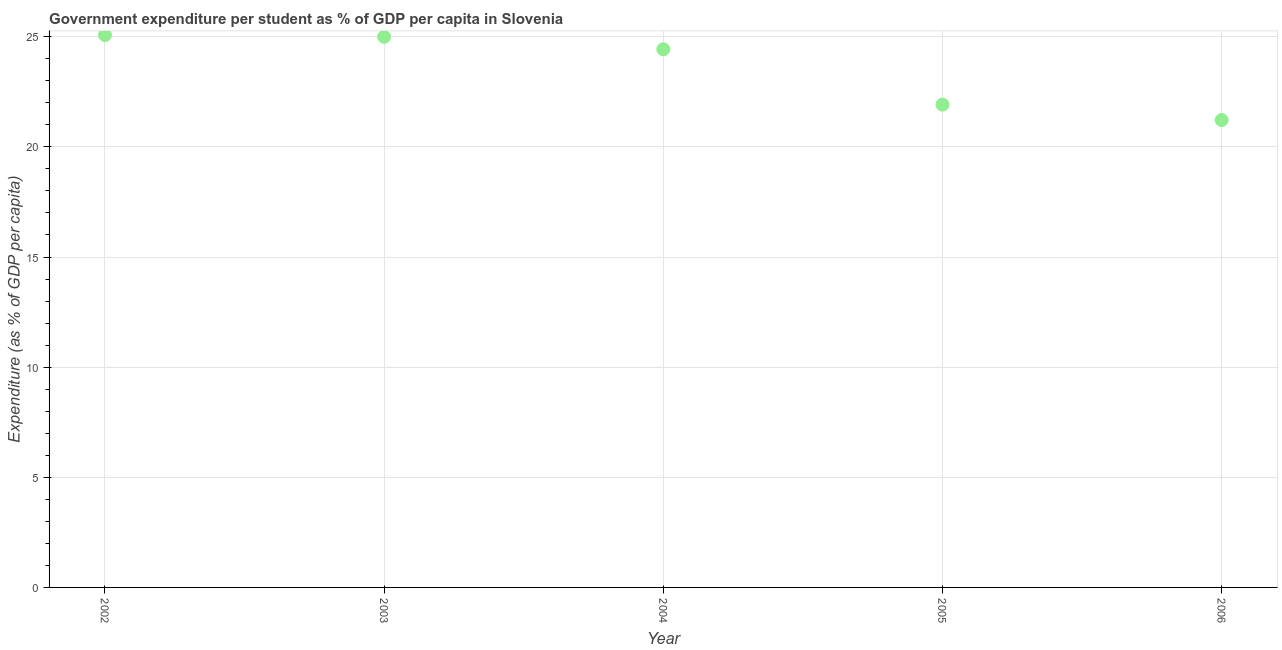What is the government expenditure per student in 2004?
Your response must be concise. 24.43. Across all years, what is the maximum government expenditure per student?
Ensure brevity in your answer.  25.08. Across all years, what is the minimum government expenditure per student?
Offer a very short reply. 21.22. In which year was the government expenditure per student maximum?
Your response must be concise. 2002. In which year was the government expenditure per student minimum?
Your answer should be very brief. 2006. What is the sum of the government expenditure per student?
Your answer should be very brief. 117.64. What is the difference between the government expenditure per student in 2002 and 2006?
Give a very brief answer. 3.86. What is the average government expenditure per student per year?
Provide a succinct answer. 23.53. What is the median government expenditure per student?
Offer a very short reply. 24.43. Do a majority of the years between 2006 and 2002 (inclusive) have government expenditure per student greater than 9 %?
Provide a short and direct response. Yes. What is the ratio of the government expenditure per student in 2002 to that in 2004?
Provide a short and direct response. 1.03. Is the government expenditure per student in 2003 less than that in 2006?
Provide a short and direct response. No. What is the difference between the highest and the second highest government expenditure per student?
Give a very brief answer. 0.08. What is the difference between the highest and the lowest government expenditure per student?
Give a very brief answer. 3.86. How many dotlines are there?
Ensure brevity in your answer.  1. How many years are there in the graph?
Your answer should be compact. 5. What is the difference between two consecutive major ticks on the Y-axis?
Ensure brevity in your answer.  5. What is the title of the graph?
Offer a very short reply. Government expenditure per student as % of GDP per capita in Slovenia. What is the label or title of the X-axis?
Make the answer very short. Year. What is the label or title of the Y-axis?
Your answer should be very brief. Expenditure (as % of GDP per capita). What is the Expenditure (as % of GDP per capita) in 2002?
Give a very brief answer. 25.08. What is the Expenditure (as % of GDP per capita) in 2003?
Offer a very short reply. 25. What is the Expenditure (as % of GDP per capita) in 2004?
Provide a short and direct response. 24.43. What is the Expenditure (as % of GDP per capita) in 2005?
Offer a very short reply. 21.92. What is the Expenditure (as % of GDP per capita) in 2006?
Provide a succinct answer. 21.22. What is the difference between the Expenditure (as % of GDP per capita) in 2002 and 2003?
Give a very brief answer. 0.08. What is the difference between the Expenditure (as % of GDP per capita) in 2002 and 2004?
Make the answer very short. 0.64. What is the difference between the Expenditure (as % of GDP per capita) in 2002 and 2005?
Provide a succinct answer. 3.16. What is the difference between the Expenditure (as % of GDP per capita) in 2002 and 2006?
Ensure brevity in your answer.  3.86. What is the difference between the Expenditure (as % of GDP per capita) in 2003 and 2004?
Ensure brevity in your answer.  0.57. What is the difference between the Expenditure (as % of GDP per capita) in 2003 and 2005?
Ensure brevity in your answer.  3.08. What is the difference between the Expenditure (as % of GDP per capita) in 2003 and 2006?
Provide a succinct answer. 3.78. What is the difference between the Expenditure (as % of GDP per capita) in 2004 and 2005?
Provide a short and direct response. 2.51. What is the difference between the Expenditure (as % of GDP per capita) in 2004 and 2006?
Offer a very short reply. 3.21. What is the difference between the Expenditure (as % of GDP per capita) in 2005 and 2006?
Give a very brief answer. 0.7. What is the ratio of the Expenditure (as % of GDP per capita) in 2002 to that in 2004?
Ensure brevity in your answer.  1.03. What is the ratio of the Expenditure (as % of GDP per capita) in 2002 to that in 2005?
Ensure brevity in your answer.  1.14. What is the ratio of the Expenditure (as % of GDP per capita) in 2002 to that in 2006?
Make the answer very short. 1.18. What is the ratio of the Expenditure (as % of GDP per capita) in 2003 to that in 2004?
Your response must be concise. 1.02. What is the ratio of the Expenditure (as % of GDP per capita) in 2003 to that in 2005?
Your response must be concise. 1.14. What is the ratio of the Expenditure (as % of GDP per capita) in 2003 to that in 2006?
Provide a succinct answer. 1.18. What is the ratio of the Expenditure (as % of GDP per capita) in 2004 to that in 2005?
Offer a very short reply. 1.11. What is the ratio of the Expenditure (as % of GDP per capita) in 2004 to that in 2006?
Provide a short and direct response. 1.15. What is the ratio of the Expenditure (as % of GDP per capita) in 2005 to that in 2006?
Make the answer very short. 1.03. 